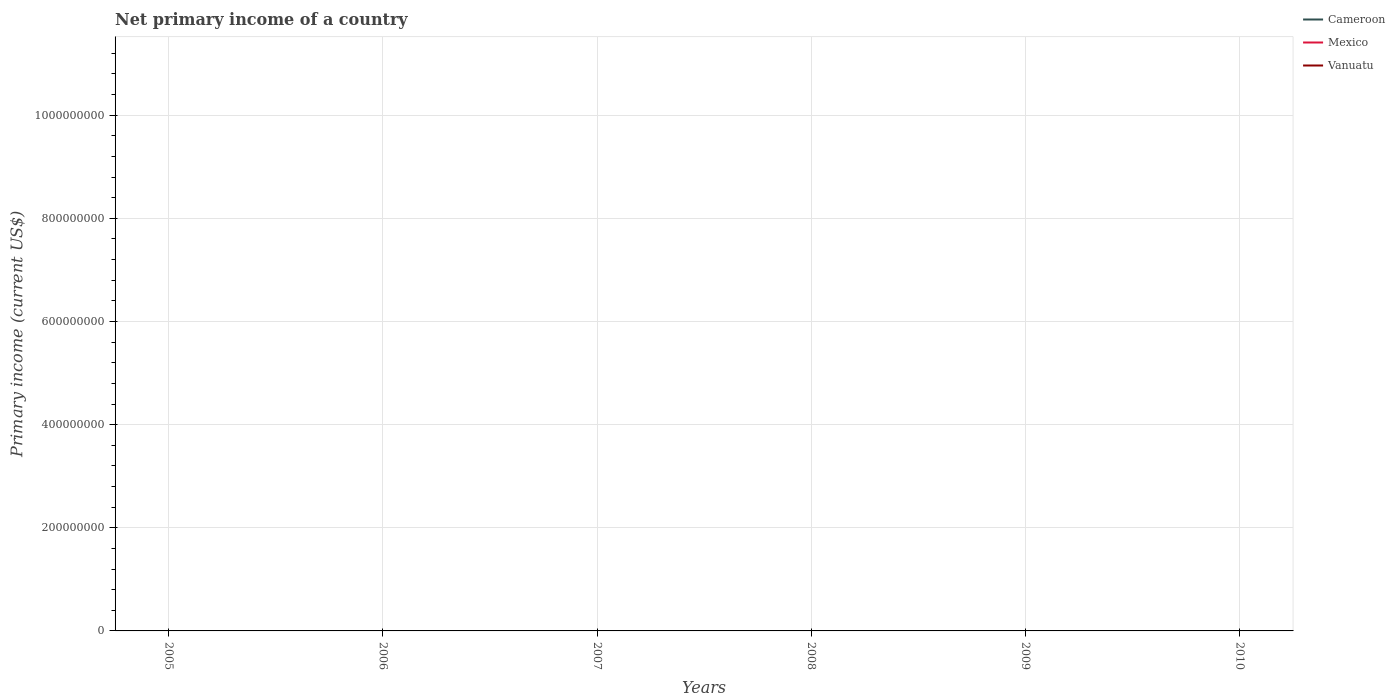How many different coloured lines are there?
Ensure brevity in your answer.  0. Does the line corresponding to Mexico intersect with the line corresponding to Cameroon?
Offer a very short reply. No. Across all years, what is the maximum primary income in Vanuatu?
Your answer should be very brief. 0. Is the primary income in Mexico strictly greater than the primary income in Cameroon over the years?
Make the answer very short. Yes. How many lines are there?
Provide a succinct answer. 0. How many years are there in the graph?
Provide a succinct answer. 6. Are the values on the major ticks of Y-axis written in scientific E-notation?
Your answer should be very brief. No. Does the graph contain any zero values?
Give a very brief answer. Yes. Does the graph contain grids?
Your response must be concise. Yes. How many legend labels are there?
Your answer should be very brief. 3. How are the legend labels stacked?
Make the answer very short. Vertical. What is the title of the graph?
Ensure brevity in your answer.  Net primary income of a country. Does "Barbados" appear as one of the legend labels in the graph?
Your response must be concise. No. What is the label or title of the Y-axis?
Give a very brief answer. Primary income (current US$). What is the Primary income (current US$) in Cameroon in 2005?
Your response must be concise. 0. What is the Primary income (current US$) of Vanuatu in 2005?
Provide a short and direct response. 0. What is the Primary income (current US$) of Cameroon in 2006?
Ensure brevity in your answer.  0. What is the Primary income (current US$) in Mexico in 2007?
Give a very brief answer. 0. What is the Primary income (current US$) in Vanuatu in 2007?
Your answer should be very brief. 0. What is the Primary income (current US$) in Mexico in 2008?
Ensure brevity in your answer.  0. What is the Primary income (current US$) of Cameroon in 2009?
Keep it short and to the point. 0. What is the Primary income (current US$) of Mexico in 2009?
Provide a short and direct response. 0. What is the Primary income (current US$) in Mexico in 2010?
Keep it short and to the point. 0. What is the Primary income (current US$) in Vanuatu in 2010?
Keep it short and to the point. 0. What is the total Primary income (current US$) of Mexico in the graph?
Your response must be concise. 0. What is the average Primary income (current US$) of Vanuatu per year?
Keep it short and to the point. 0. 